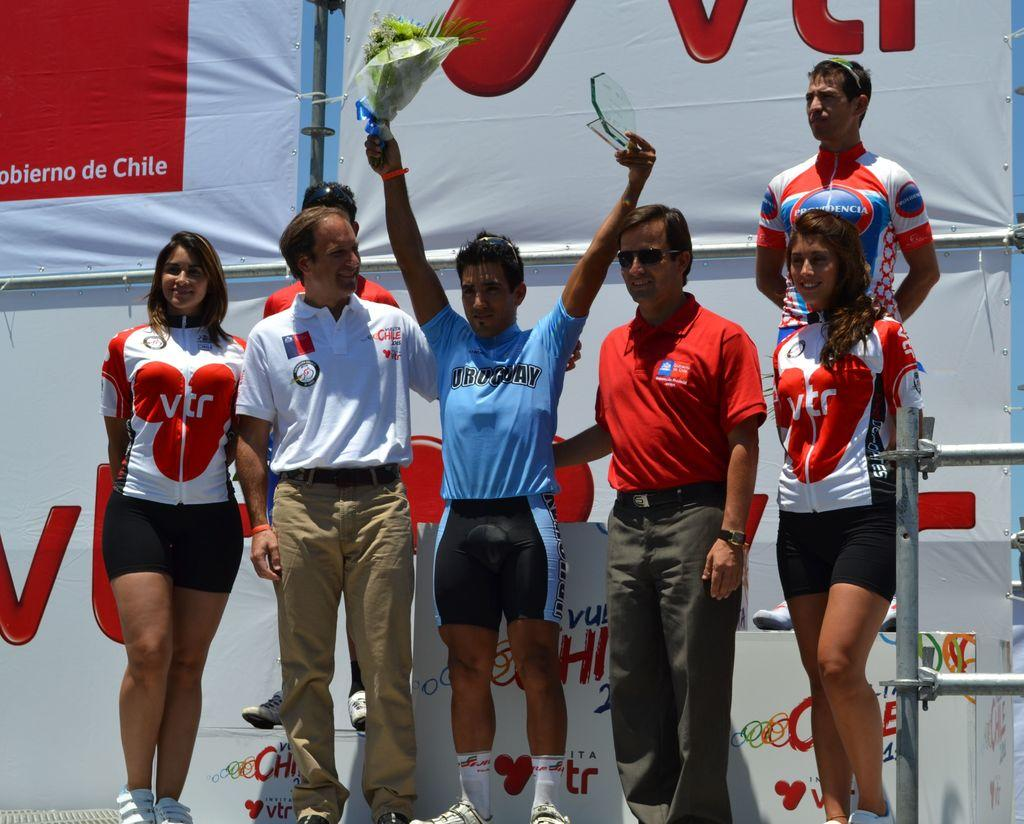<image>
Relay a brief, clear account of the picture shown. A man in a shirt that says Uruguay holds up a bouquet of flowers and an award. 